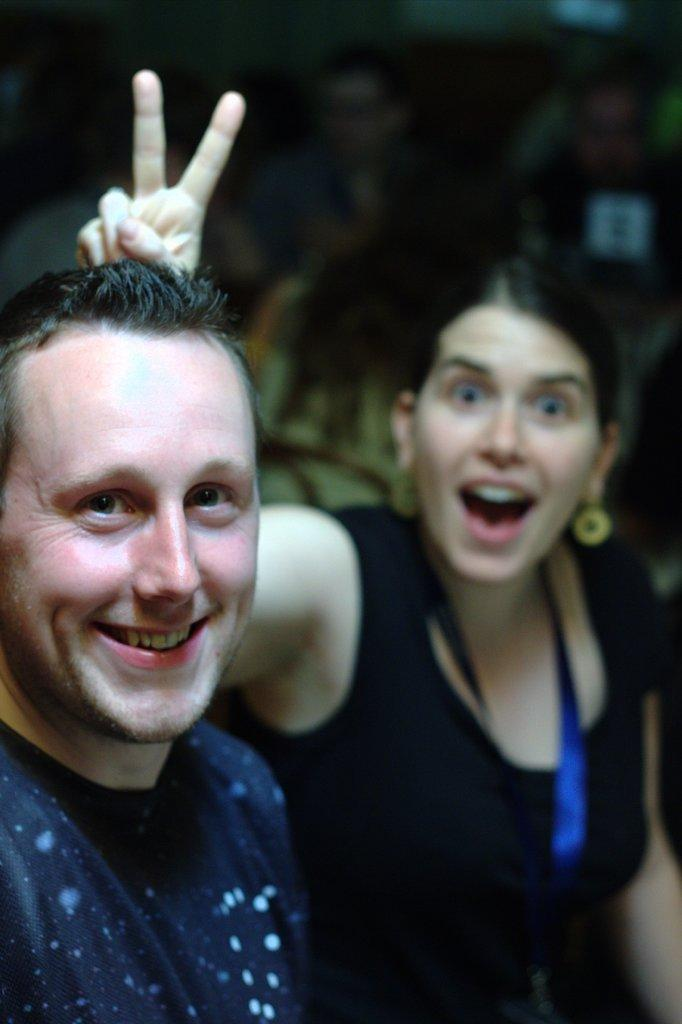Who is on the left side of the image? There is a man on the left side of the image. What is the man doing in the image? The man is smiling in the image. What is the man wearing in the image? The man is wearing a t-shirt in the image. Who is on the right side of the image? There is a woman on the right side of the image. What is the woman doing in the image? The woman is showing her two fingers in the image. What is the woman wearing in the image? The woman is wearing a black color top in the image. What type of tax is being discussed in the image? There is no mention of tax or any discussion about it in the image. Where is the park located in the image? There is no park present in the image. 